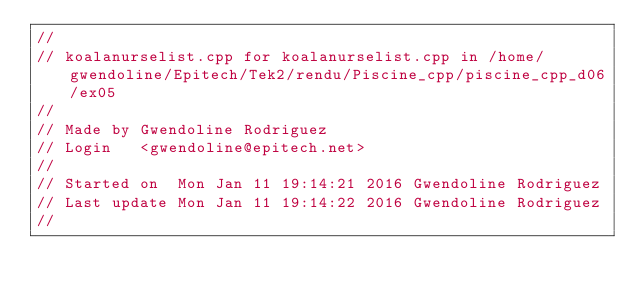<code> <loc_0><loc_0><loc_500><loc_500><_C++_>//
// koalanurselist.cpp for koalanurselist.cpp in /home/gwendoline/Epitech/Tek2/rendu/Piscine_cpp/piscine_cpp_d06/ex05
//
// Made by Gwendoline Rodriguez
// Login   <gwendoline@epitech.net>
//
// Started on  Mon Jan 11 19:14:21 2016 Gwendoline Rodriguez
// Last update Mon Jan 11 19:14:22 2016 Gwendoline Rodriguez
//
</code> 